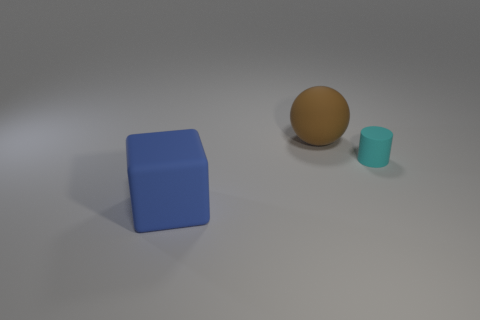Add 2 large rubber blocks. How many objects exist? 5 Subtract all spheres. How many objects are left? 2 Subtract all blue things. Subtract all big blue blocks. How many objects are left? 1 Add 3 blue matte cubes. How many blue matte cubes are left? 4 Add 3 small yellow rubber spheres. How many small yellow rubber spheres exist? 3 Subtract 0 green balls. How many objects are left? 3 